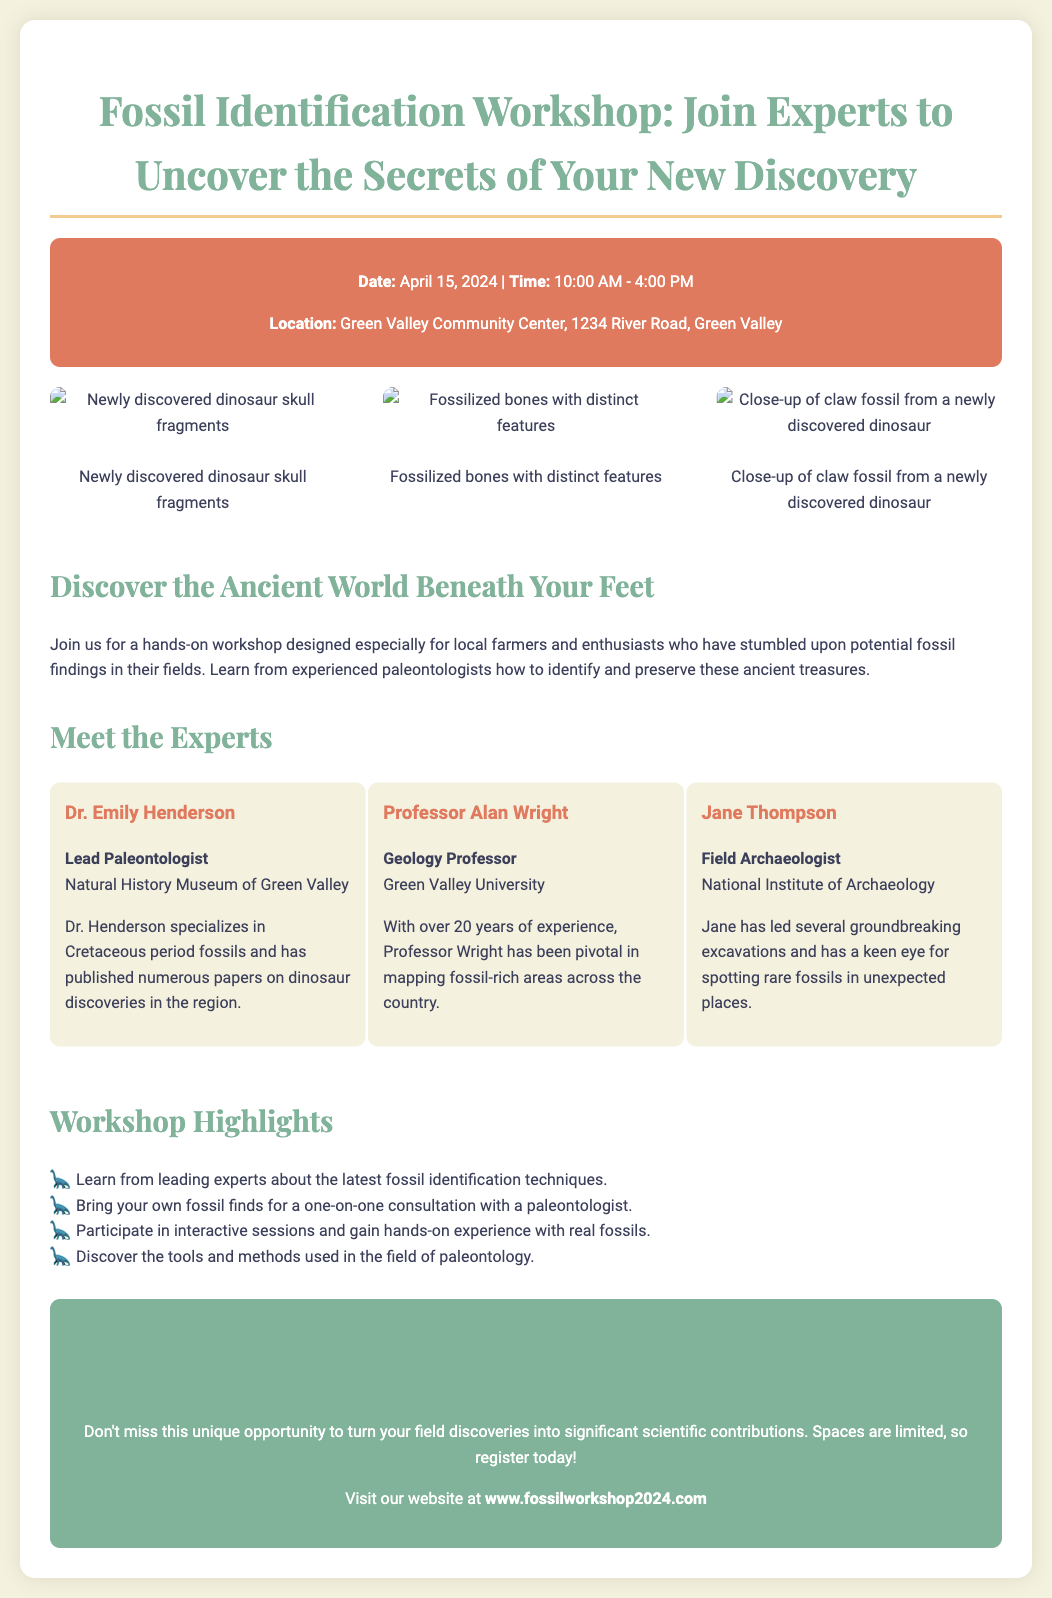What is the date of the workshop? The date of the workshop is explicitly mentioned in the event details section.
Answer: April 15, 2024 Where is the workshop being held? The location of the workshop is provided under the event details section.
Answer: Green Valley Community Center Who is the lead paleontologist? The expert profiles section includes the names and titles of the experts.
Answer: Dr. Emily Henderson What time does the workshop start? The time of the workshop is stated in the event details section.
Answer: 10:00 AM What artifact types can be brought to the workshop? The workshop highlights section mentions a specific activity related to bringing items for consultation.
Answer: Fossils Who has over 20 years of experience? This information can be found in the expert profiles section, which details their experience.
Answer: Professor Alan Wright What is the website for registration? The registration information mentions the website where attendees can register.
Answer: www.fossilworkshop2024.com What color is the event details background? The styling of the document indicates the color used for the event details section.
Answer: e07a5f What is a workshop highlight? Information about workshop highlights is listed, providing multiple examples of the workshop's features.
Answer: Learn from leading experts about the latest fossil identification techniques 